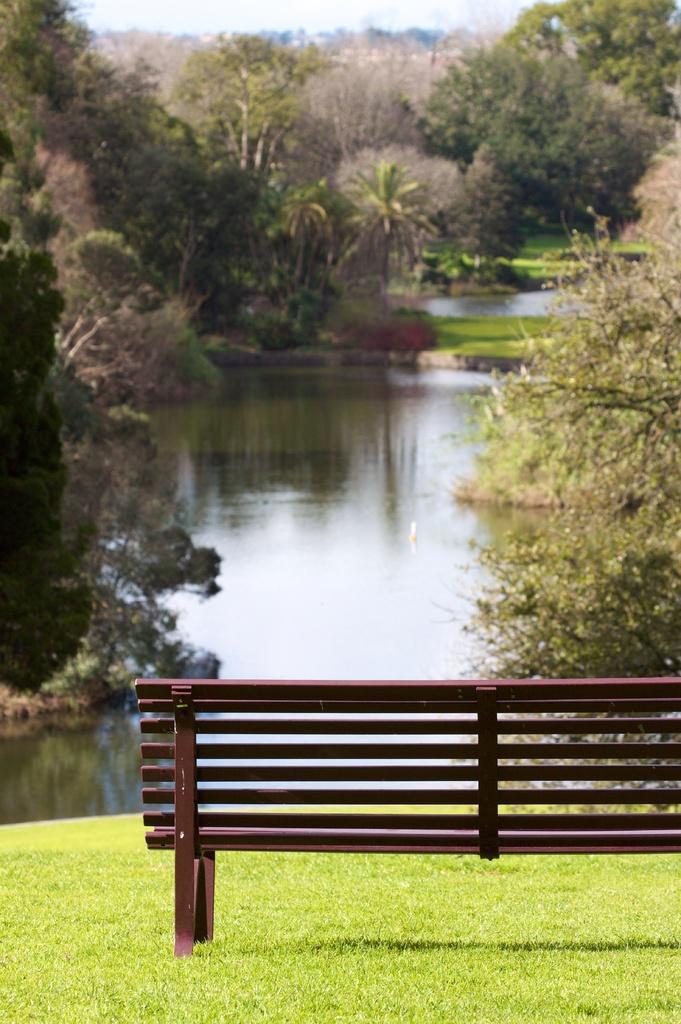How would you summarize this image in a sentence or two? In the image there is a bench on the grass land with a lake in front of it and trees on either side of it and above its sky. 